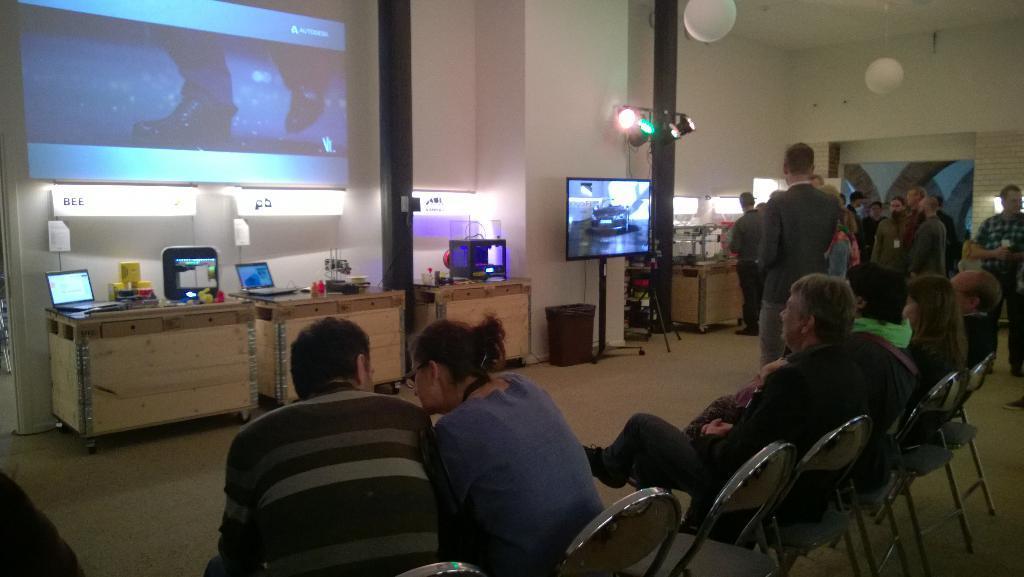Describe this image in one or two sentences. In this image I can see people where few are sitting on chairs and rest all are standing. In the background I can see few tables, a television, few lights, a screen over here and few white colour things on ceiling. On these tables I can see few laptops, few monitors and few other stuffs. 